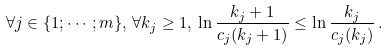Convert formula to latex. <formula><loc_0><loc_0><loc_500><loc_500>\forall j \in \{ 1 ; \cdots ; m \} , \, \forall k _ { j } \geq 1 , \, \ln \frac { k _ { j } + 1 } { c _ { j } ( k _ { j } + 1 ) } \leq \ln \frac { k _ { j } } { c _ { j } ( k _ { j } ) } \, .</formula> 